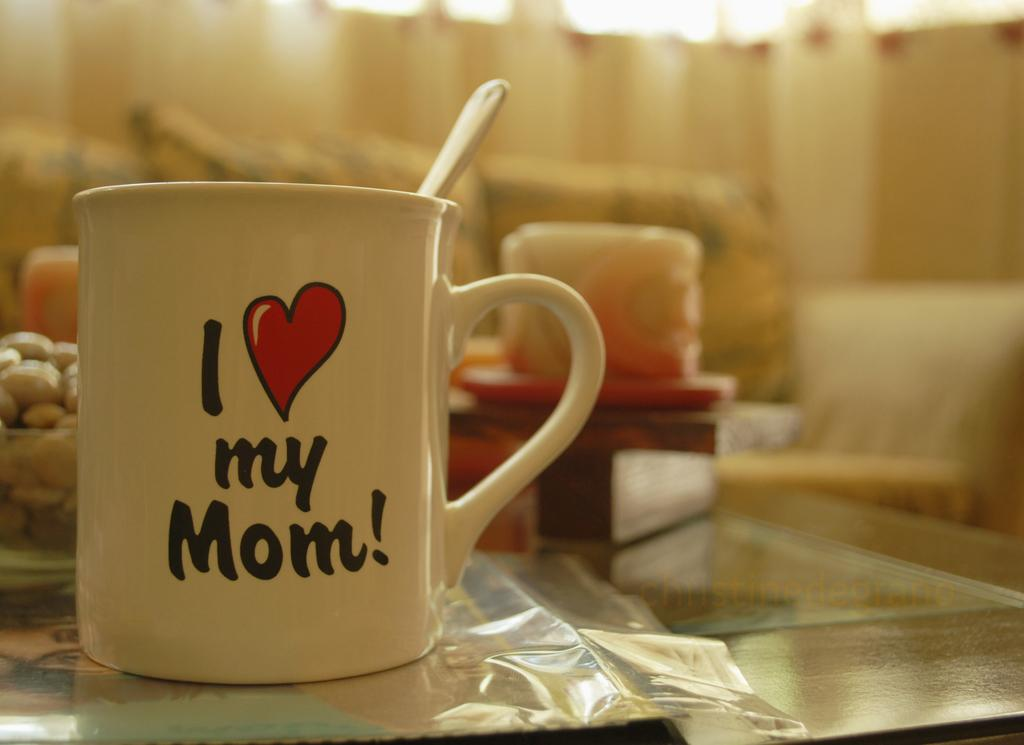<image>
Present a compact description of the photo's key features. White coffee mug with a nice saying about moms. 